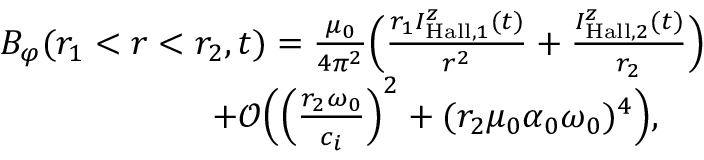Convert formula to latex. <formula><loc_0><loc_0><loc_500><loc_500>\begin{array} { r l } & { B _ { \varphi } ( r _ { 1 } < r < r _ { 2 } , t ) = \frac { \mu _ { 0 } } { 4 \pi ^ { 2 } } \left ( \frac { r _ { 1 } I _ { H a l l , 1 } ^ { z } ( t ) } { r ^ { 2 } } + \frac { I _ { H a l l , 2 } ^ { z } ( t ) } { r _ { 2 } } \right ) } \\ & { \quad + \mathcal { O } \left ( \left ( \frac { r _ { 2 } \omega _ { 0 } } { c _ { i } } \right ) ^ { 2 } + ( r _ { 2 } \mu _ { 0 } \alpha _ { 0 } \omega _ { 0 } ) ^ { 4 } \right ) , } \end{array}</formula> 